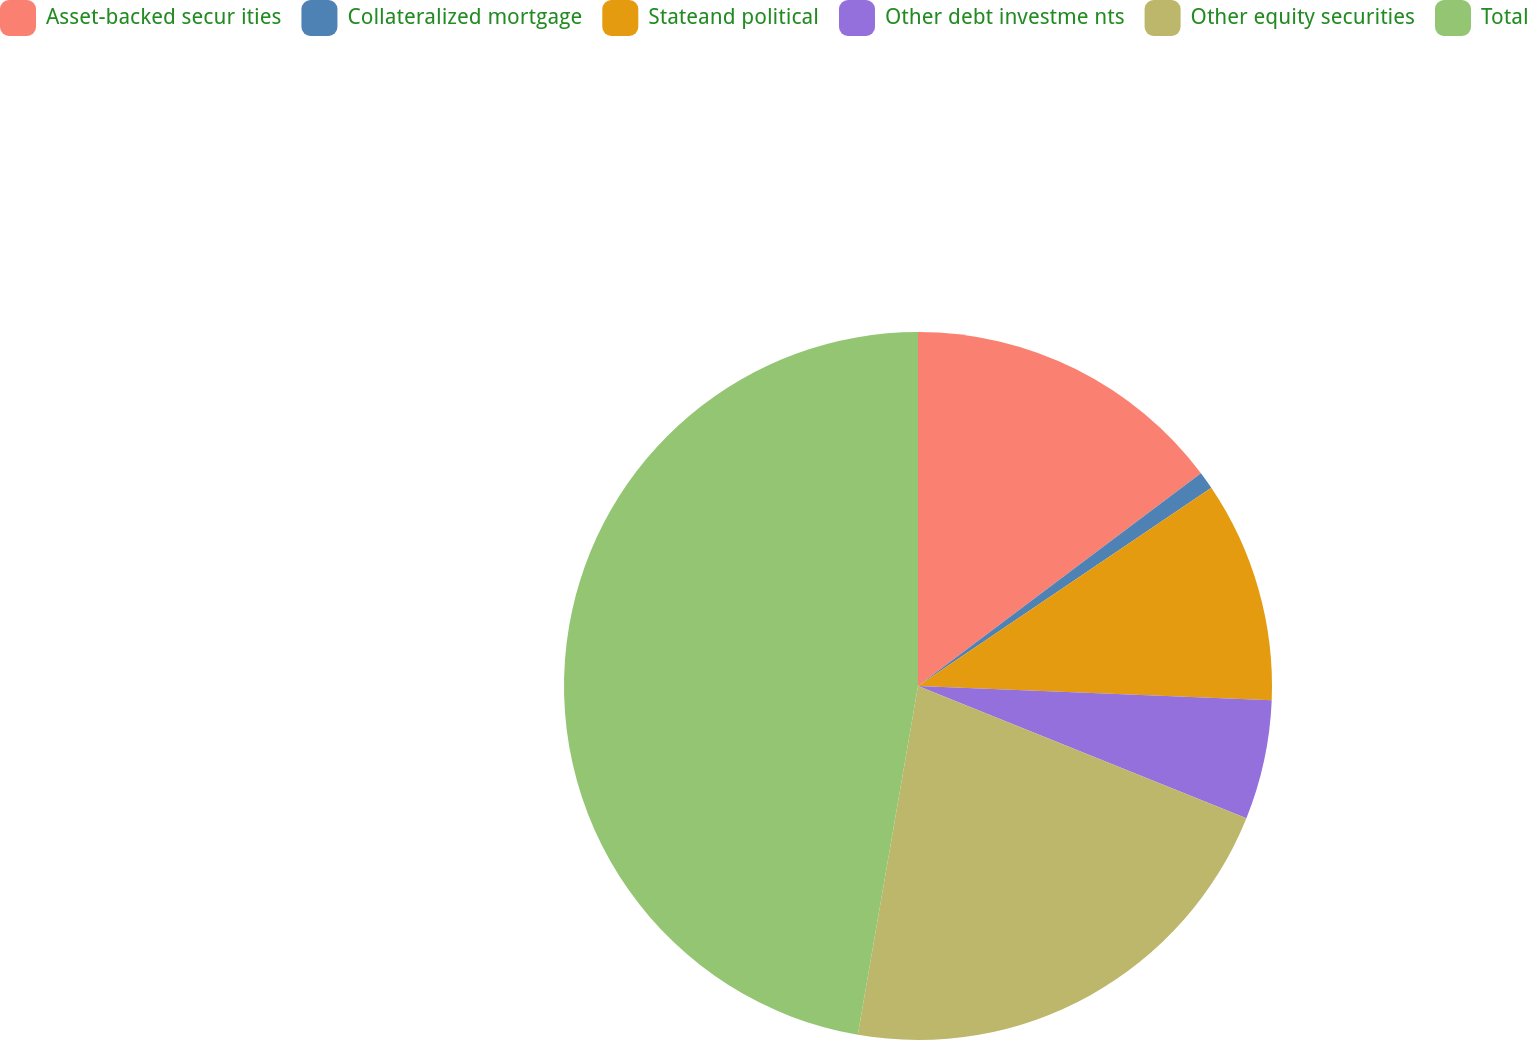Convert chart. <chart><loc_0><loc_0><loc_500><loc_500><pie_chart><fcel>Asset-backed secur ities<fcel>Collateralized mortgage<fcel>Stateand political<fcel>Other debt investme nts<fcel>Other equity securities<fcel>Total<nl><fcel>14.74%<fcel>0.8%<fcel>10.1%<fcel>5.45%<fcel>21.63%<fcel>47.28%<nl></chart> 